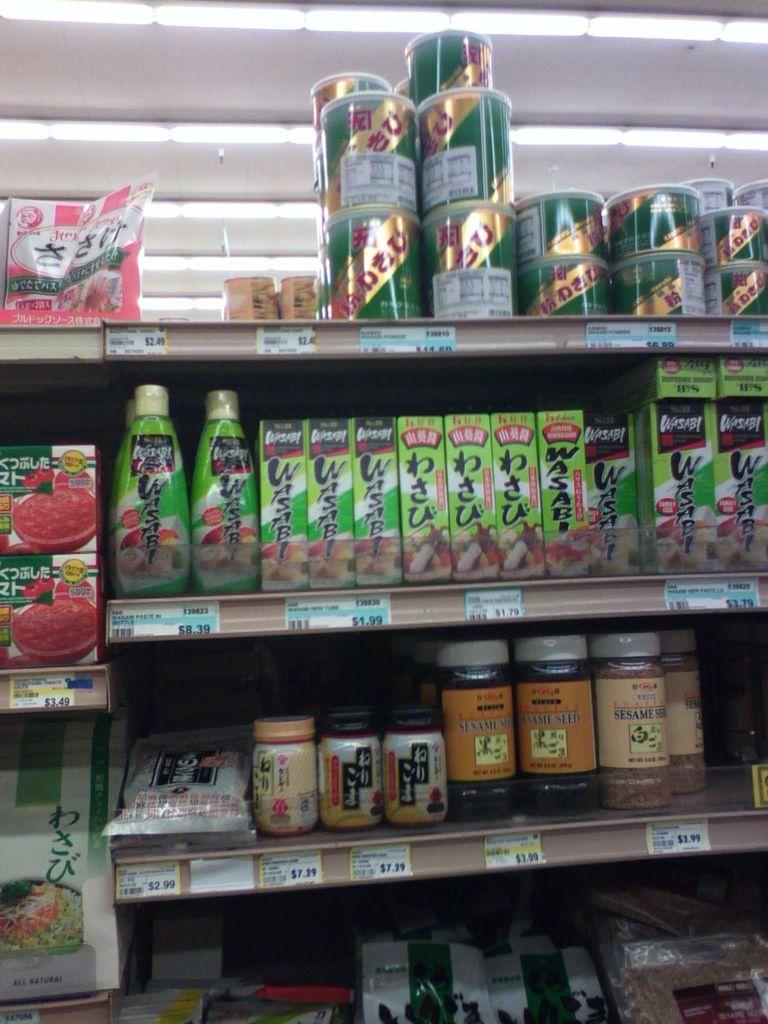What type of storage units are visible in the image? There are shelves in the image. What items can be seen on the shelves? There are bottles and jars on the shelves. Are there any indications of the items' prices in the image? Yes, price tags are present in the image. What other objects can be seen on the shelves? There are other objects on the shelves besides bottles and jars. What can be seen in the background of the image? There is a roof visible in the background of the image. What type of cream can be seen being poured into the fuel tank in the image? There is no cream or fuel tank present in the image; it features shelves with bottles, jars, and other objects. Can you hear the voice of the person who arranged the shelves in the image? There is no voice present in the image, as it is a still photograph. 